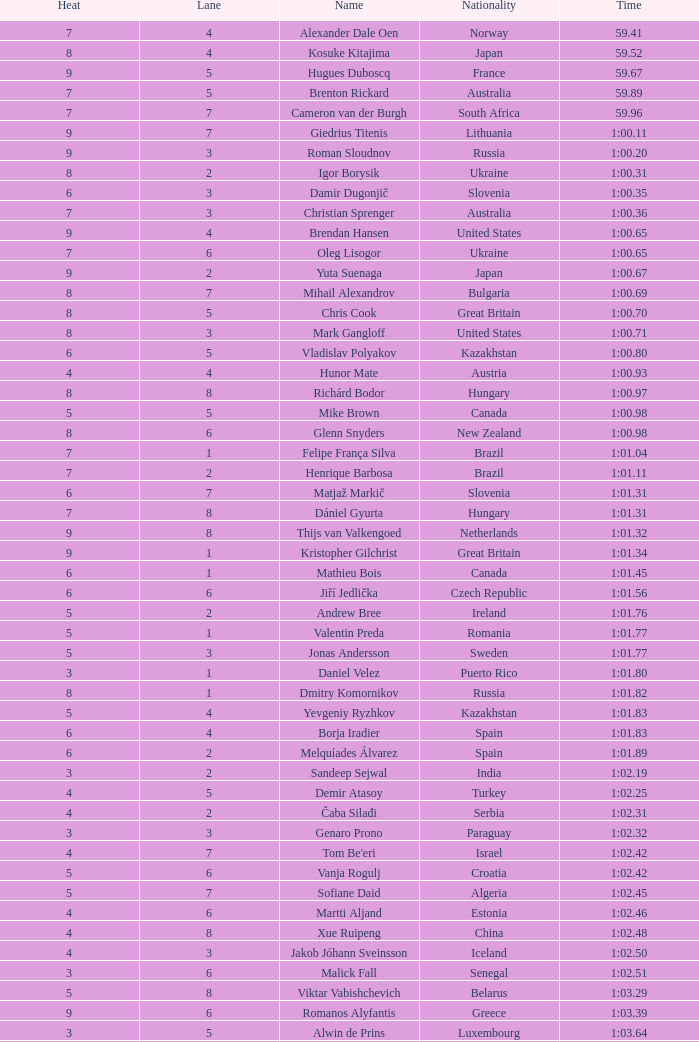Could you help me parse every detail presented in this table? {'header': ['Heat', 'Lane', 'Name', 'Nationality', 'Time'], 'rows': [['7', '4', 'Alexander Dale Oen', 'Norway', '59.41'], ['8', '4', 'Kosuke Kitajima', 'Japan', '59.52'], ['9', '5', 'Hugues Duboscq', 'France', '59.67'], ['7', '5', 'Brenton Rickard', 'Australia', '59.89'], ['7', '7', 'Cameron van der Burgh', 'South Africa', '59.96'], ['9', '7', 'Giedrius Titenis', 'Lithuania', '1:00.11'], ['9', '3', 'Roman Sloudnov', 'Russia', '1:00.20'], ['8', '2', 'Igor Borysik', 'Ukraine', '1:00.31'], ['6', '3', 'Damir Dugonjič', 'Slovenia', '1:00.35'], ['7', '3', 'Christian Sprenger', 'Australia', '1:00.36'], ['9', '4', 'Brendan Hansen', 'United States', '1:00.65'], ['7', '6', 'Oleg Lisogor', 'Ukraine', '1:00.65'], ['9', '2', 'Yuta Suenaga', 'Japan', '1:00.67'], ['8', '7', 'Mihail Alexandrov', 'Bulgaria', '1:00.69'], ['8', '5', 'Chris Cook', 'Great Britain', '1:00.70'], ['8', '3', 'Mark Gangloff', 'United States', '1:00.71'], ['6', '5', 'Vladislav Polyakov', 'Kazakhstan', '1:00.80'], ['4', '4', 'Hunor Mate', 'Austria', '1:00.93'], ['8', '8', 'Richárd Bodor', 'Hungary', '1:00.97'], ['5', '5', 'Mike Brown', 'Canada', '1:00.98'], ['8', '6', 'Glenn Snyders', 'New Zealand', '1:00.98'], ['7', '1', 'Felipe França Silva', 'Brazil', '1:01.04'], ['7', '2', 'Henrique Barbosa', 'Brazil', '1:01.11'], ['6', '7', 'Matjaž Markič', 'Slovenia', '1:01.31'], ['7', '8', 'Dániel Gyurta', 'Hungary', '1:01.31'], ['9', '8', 'Thijs van Valkengoed', 'Netherlands', '1:01.32'], ['9', '1', 'Kristopher Gilchrist', 'Great Britain', '1:01.34'], ['6', '1', 'Mathieu Bois', 'Canada', '1:01.45'], ['6', '6', 'Jiří Jedlička', 'Czech Republic', '1:01.56'], ['5', '2', 'Andrew Bree', 'Ireland', '1:01.76'], ['5', '1', 'Valentin Preda', 'Romania', '1:01.77'], ['5', '3', 'Jonas Andersson', 'Sweden', '1:01.77'], ['3', '1', 'Daniel Velez', 'Puerto Rico', '1:01.80'], ['8', '1', 'Dmitry Komornikov', 'Russia', '1:01.82'], ['5', '4', 'Yevgeniy Ryzhkov', 'Kazakhstan', '1:01.83'], ['6', '4', 'Borja Iradier', 'Spain', '1:01.83'], ['6', '2', 'Melquíades Álvarez', 'Spain', '1:01.89'], ['3', '2', 'Sandeep Sejwal', 'India', '1:02.19'], ['4', '5', 'Demir Atasoy', 'Turkey', '1:02.25'], ['4', '2', 'Čaba Silađi', 'Serbia', '1:02.31'], ['3', '3', 'Genaro Prono', 'Paraguay', '1:02.32'], ['4', '7', "Tom Be'eri", 'Israel', '1:02.42'], ['5', '6', 'Vanja Rogulj', 'Croatia', '1:02.42'], ['5', '7', 'Sofiane Daid', 'Algeria', '1:02.45'], ['4', '6', 'Martti Aljand', 'Estonia', '1:02.46'], ['4', '8', 'Xue Ruipeng', 'China', '1:02.48'], ['4', '3', 'Jakob Jóhann Sveinsson', 'Iceland', '1:02.50'], ['3', '6', 'Malick Fall', 'Senegal', '1:02.51'], ['5', '8', 'Viktar Vabishchevich', 'Belarus', '1:03.29'], ['9', '6', 'Romanos Alyfantis', 'Greece', '1:03.39'], ['3', '5', 'Alwin de Prins', 'Luxembourg', '1:03.64'], ['3', '4', 'Sergio Andres Ferreyra', 'Argentina', '1:03.65'], ['2', '3', 'Edgar Crespo', 'Panama', '1:03.72'], ['2', '4', 'Sergiu Postica', 'Moldova', '1:03.83'], ['3', '8', 'Andrei Cross', 'Barbados', '1:04.57'], ['3', '7', 'Ivan Demyanenko', 'Uzbekistan', '1:05.14'], ['2', '6', 'Wael Koubrousli', 'Lebanon', '1:06.22'], ['2', '5', 'Nguyen Huu Viet', 'Vietnam', '1:06.36'], ['2', '2', 'Erik Rajohnson', 'Madagascar', '1:08.42'], ['2', '7', 'Boldbaataryn Bütekh-Uils', 'Mongolia', '1:10.80'], ['1', '4', 'Osama Mohammed Ye Alarag', 'Qatar', '1:10.83'], ['1', '5', 'Mohammed Al-Habsi', 'Oman', '1:12.28'], ['1', '3', 'Petero Okotai', 'Cook Islands', '1:20.20'], ['6', '8', 'Alessandro Terrin', 'Italy', 'DSQ'], ['4', '1', 'Mohammad Alirezaei', 'Iran', 'DNS']]} For a heat below 5, what is the time achieved by vietnam in lane 5? 1:06.36. 